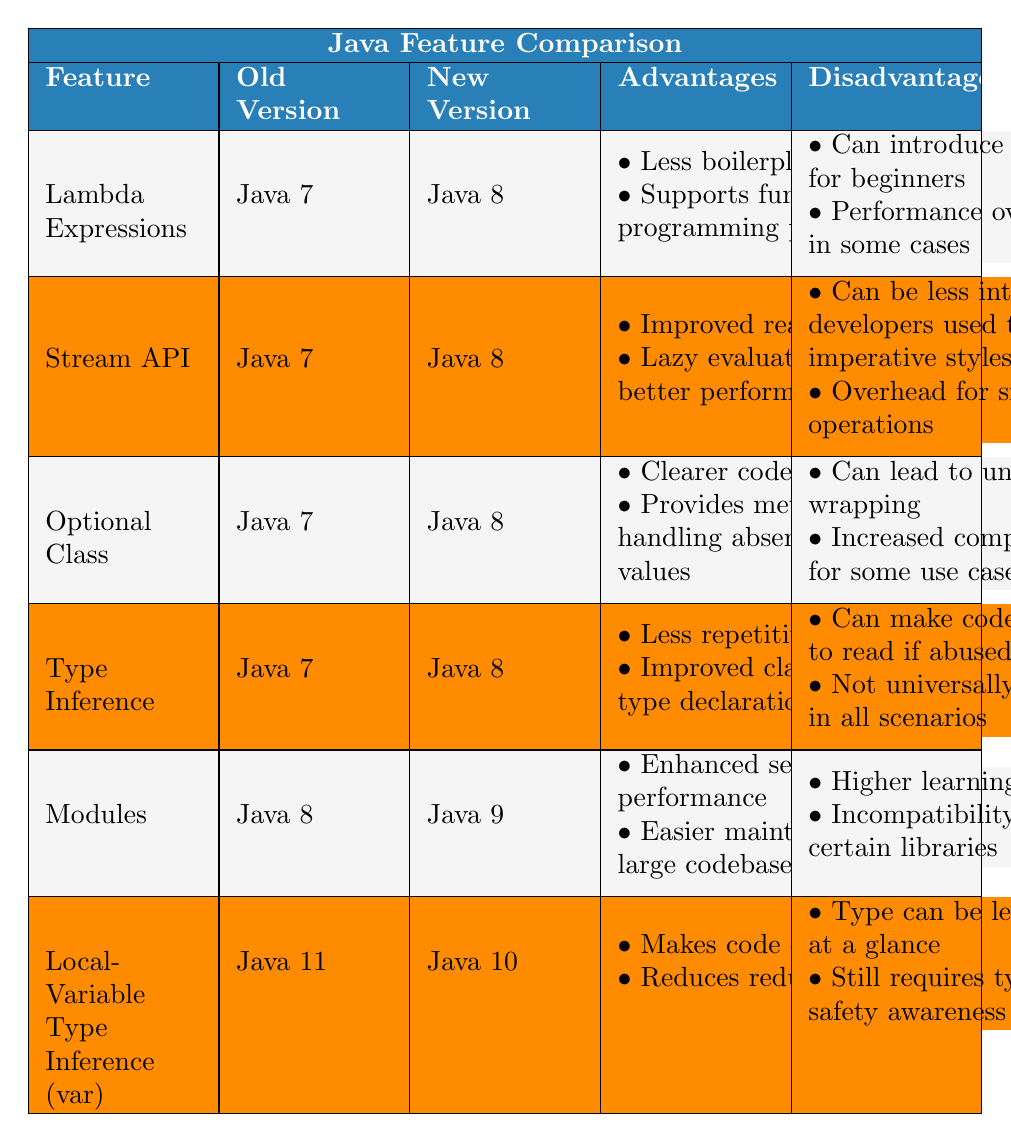What was the Old Version for Lambda Expressions? The table lists Lambda Expressions under the "Feature" column. To find the Old Version, we look at the corresponding column in that same row, which shows Java 7 as the Old Version.
Answer: Java 7 What is one advantage of using the Stream API? By looking at the row for the Stream API, we can see the Advantages column lists "Improved readability" as one of the advantages.
Answer: Improved readability Is the Optional class introduced in Java 8? We can check the Old Version column for the Optional Class and see it indicates Java 7. Therefore, the statement is false because it was present in an earlier version.
Answer: No How many advantages does Local-Variable Type Inference (var) have according to the table? The Local-Variable Type Inference (var) row indicates two advantages listed under the Advantages column, which are "Makes code cleaner" and "Reduces redundancy".
Answer: 2 Which feature has a higher learning curve, Modules or Optional Class? We compare the Disadvantages column for both features. The Modules row lists "Higher learning curve" while the Optional Class does not mention learning curve at all. Thus, Modules has the mentioned disadvantage indicating a higher learning curve.
Answer: Modules What is the difference in version between the introduction of Lambda Expressions and the Stream API? Both the Lambda Expressions and Stream API are listed under the same Old Version (Java 7) and New Version (Java 8), showing no difference in version. Hence, the difference in version is zero.
Answer: 0 Are there any features that introduced lazy evaluation as an advantage? By examining the Advantages column, we see that only the Stream API mentions “Lazy evaluation for better performance”. This indicates that it is the only feature associating lazy evaluation as an advantage.
Answer: Yes Which version introduced the Modules feature, and what is one of its advantages? The modules feature row specifies the New Version as Java 9. Furthermore, the Advantages column lists "Enhanced security and performance", which we can take as an advantage associated with this feature.
Answer: Java 9, Enhanced security and performance What is the total number of disadvantages for the Type Inference and Modules features combined? The Type Inference row lists two disadvantages: "Can make code harder to read if abused" and "Not universally supported in all scenarios," while the Modules feature lists two disadvantages as well. Thus, adding both gives us a total of four disadvantages combined.
Answer: 4 